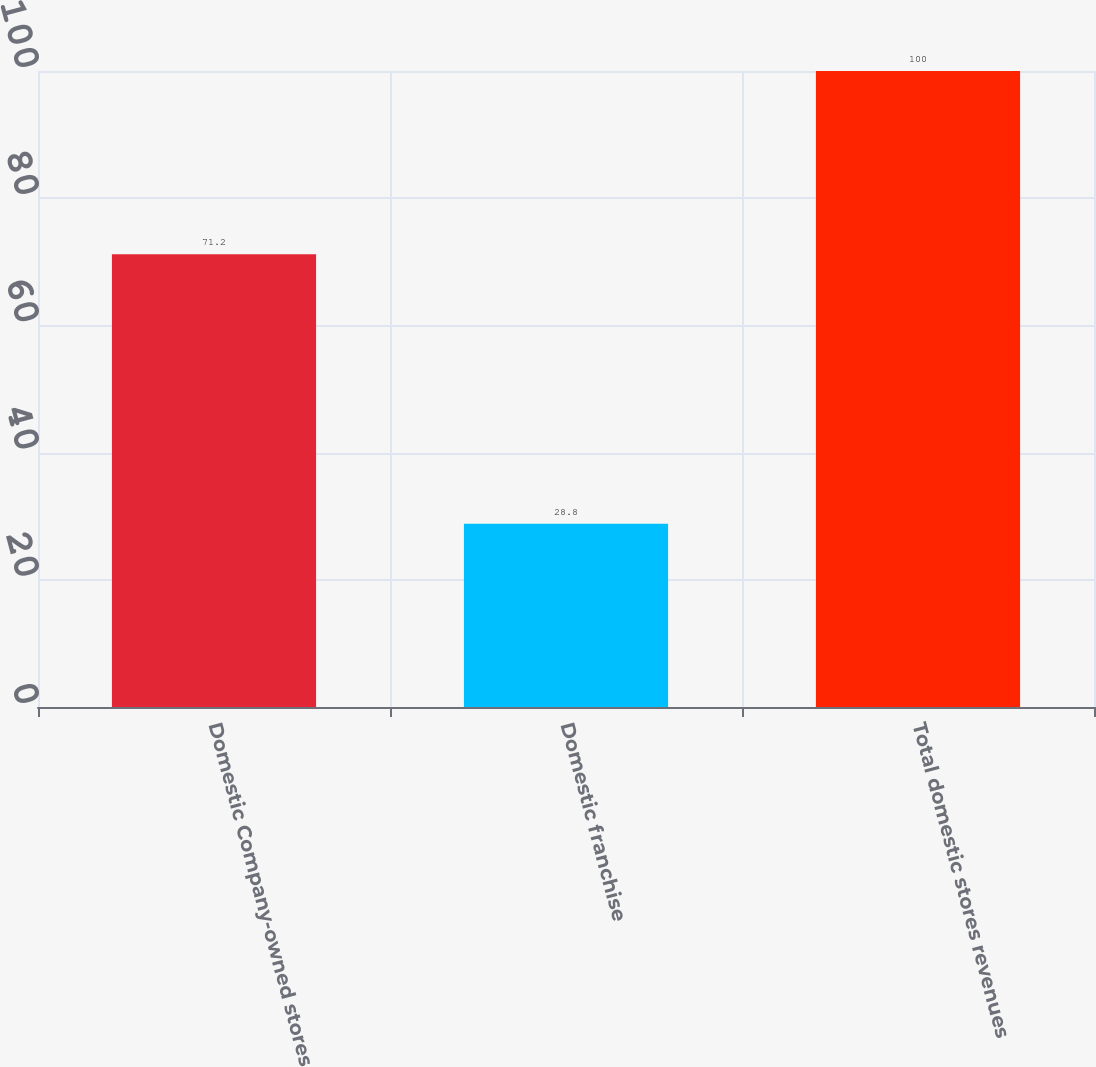<chart> <loc_0><loc_0><loc_500><loc_500><bar_chart><fcel>Domestic Company-owned stores<fcel>Domestic franchise<fcel>Total domestic stores revenues<nl><fcel>71.2<fcel>28.8<fcel>100<nl></chart> 